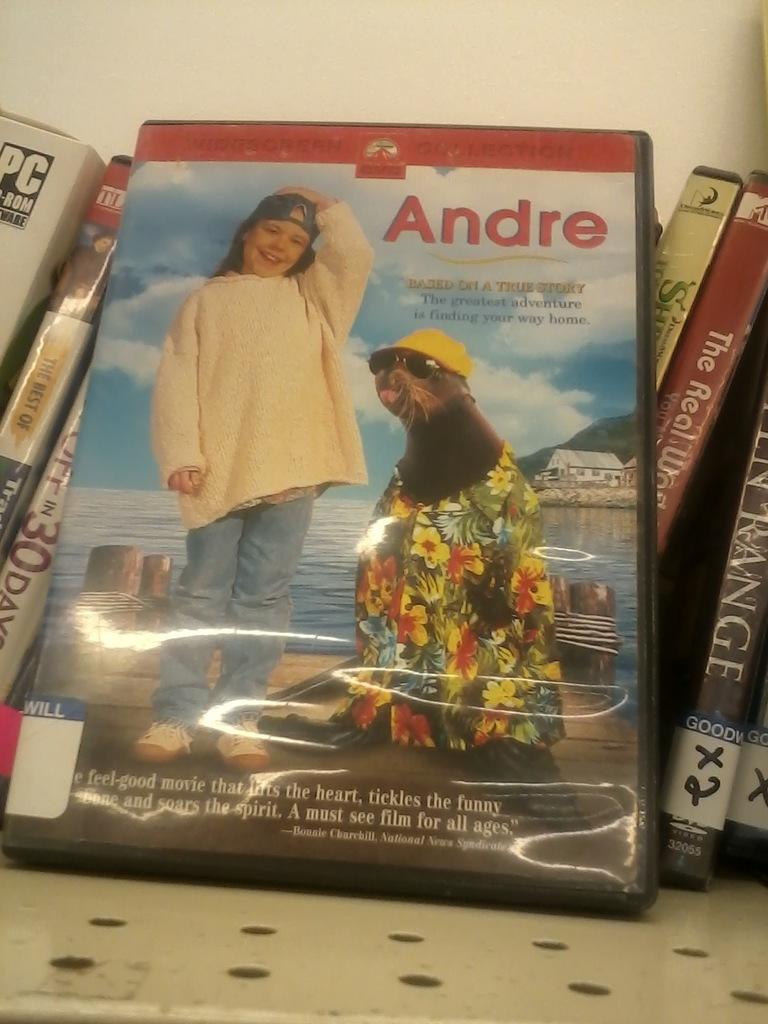What is the main object in the image? There is a DVD box with a movie label in the image. Are there any other DVD boxes visible? Yes, there are other DVD boxes behind the first DVD box with the movie label. What can be seen in the background of the image? There is a wall visible in the image. What type of pancake is being cooked on the stove in the image? There is no stove or pancake present in the image; it features a DVD box with a movie label and other DVD boxes. What color is the cord connecting the DVD player to the TV in the image? There is no DVD player or TV visible in the image, only DVD boxes and a wall. 